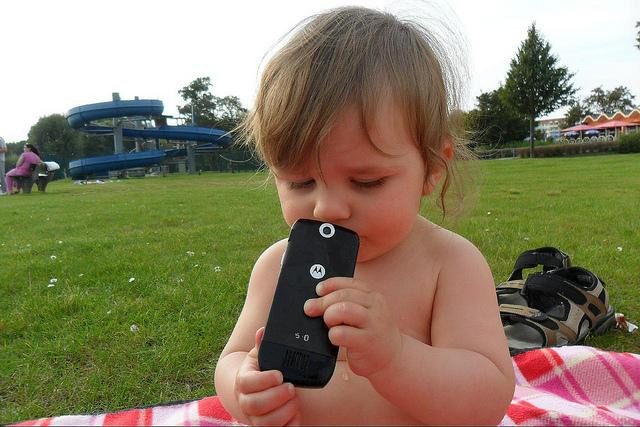What is playing with the phone? baby 